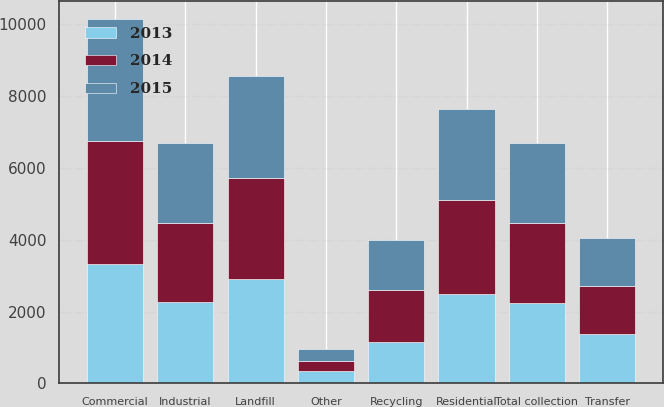<chart> <loc_0><loc_0><loc_500><loc_500><stacked_bar_chart><ecel><fcel>Commercial<fcel>Residential<fcel>Industrial<fcel>Other<fcel>Total collection<fcel>Landfill<fcel>Transfer<fcel>Recycling<nl><fcel>2013<fcel>3332<fcel>2499<fcel>2252<fcel>356<fcel>2231<fcel>2919<fcel>1377<fcel>1163<nl><fcel>2015<fcel>3393<fcel>2543<fcel>2231<fcel>340<fcel>2231<fcel>2849<fcel>1353<fcel>1370<nl><fcel>2014<fcel>3423<fcel>2608<fcel>2209<fcel>273<fcel>2231<fcel>2790<fcel>1329<fcel>1447<nl></chart> 